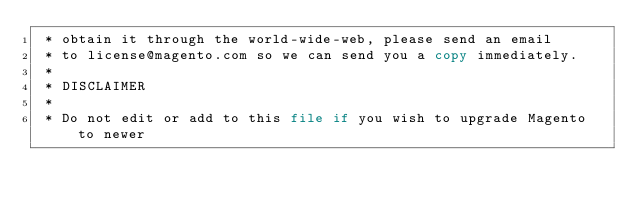<code> <loc_0><loc_0><loc_500><loc_500><_PHP_> * obtain it through the world-wide-web, please send an email
 * to license@magento.com so we can send you a copy immediately.
 *
 * DISCLAIMER
 *
 * Do not edit or add to this file if you wish to upgrade Magento to newer</code> 